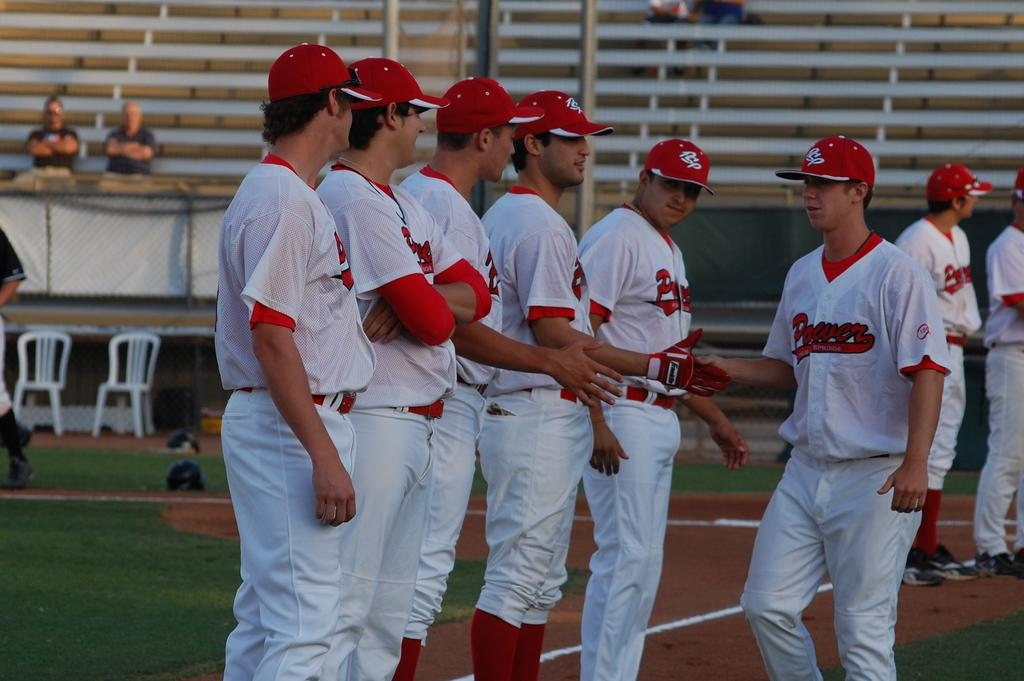<image>
Present a compact description of the photo's key features. A baseball team with the word "Power" on the uniform is lined up on the field. 